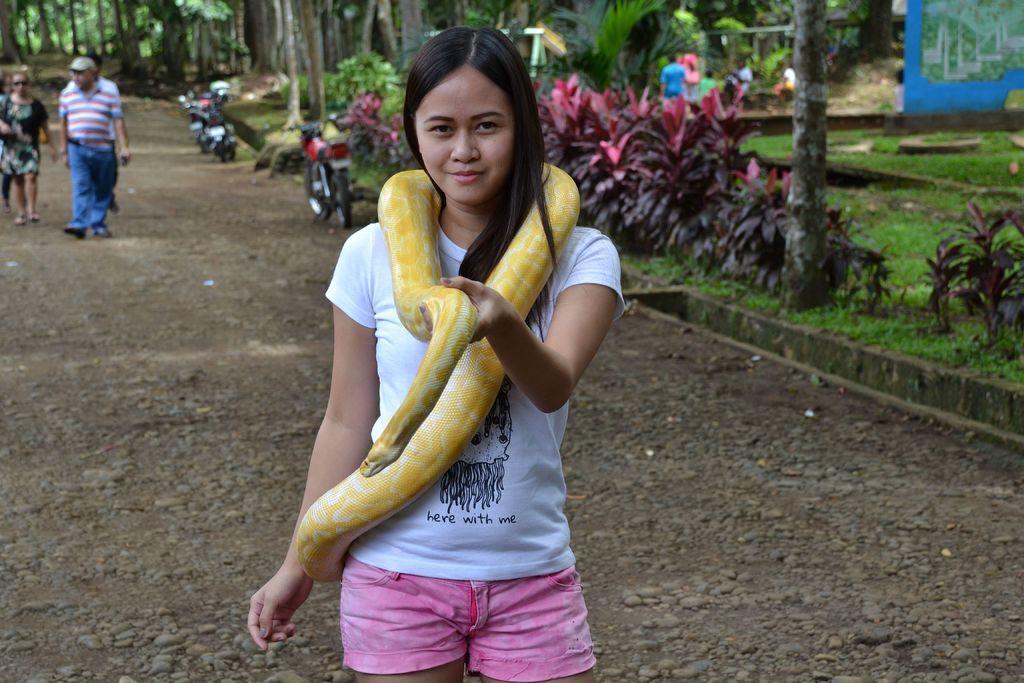Can you describe this image briefly? In this image I can see a girl is standing and holding a snake. I can see she is smiling and wearing a white t -shirt. In the background I can see few more people, vehicles, plants and trees. 